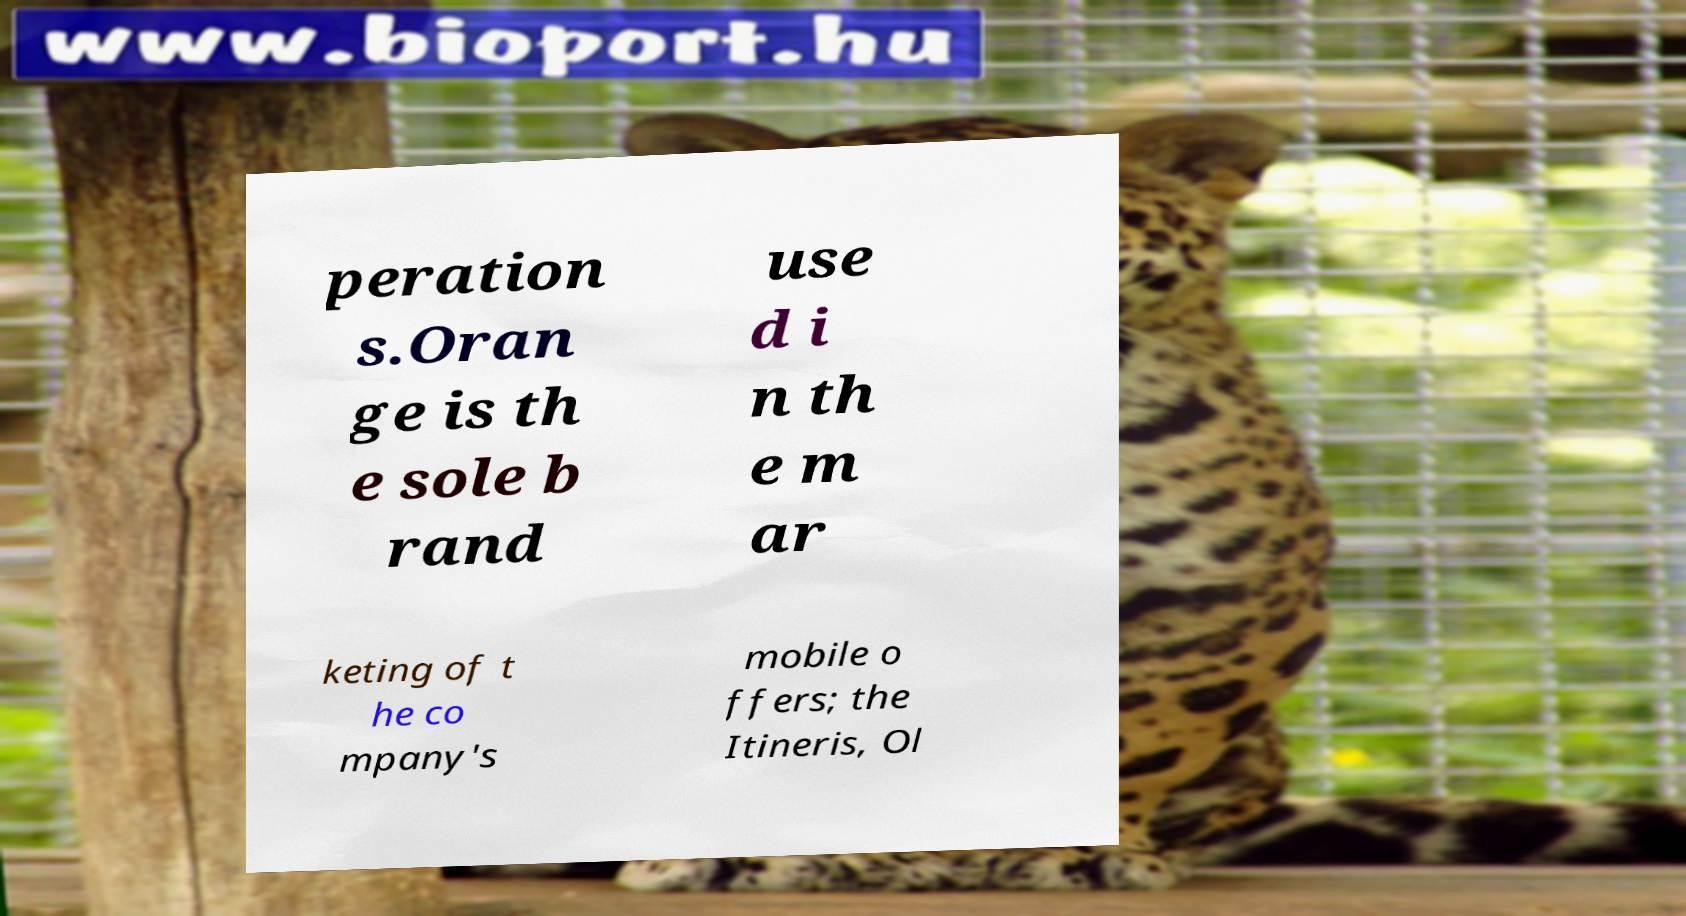Could you extract and type out the text from this image? peration s.Oran ge is th e sole b rand use d i n th e m ar keting of t he co mpany's mobile o ffers; the Itineris, Ol 